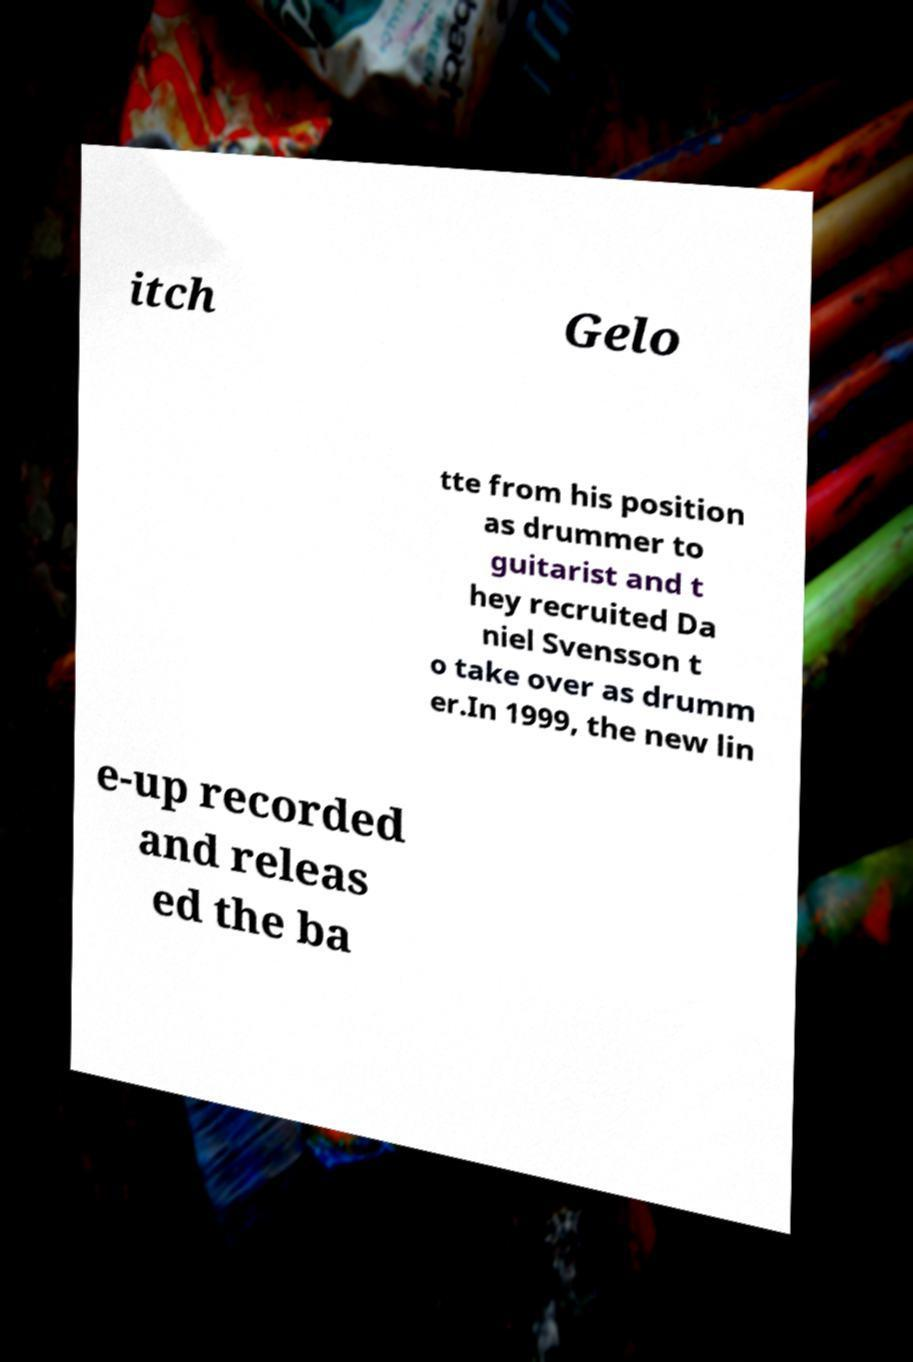Can you accurately transcribe the text from the provided image for me? itch Gelo tte from his position as drummer to guitarist and t hey recruited Da niel Svensson t o take over as drumm er.In 1999, the new lin e-up recorded and releas ed the ba 